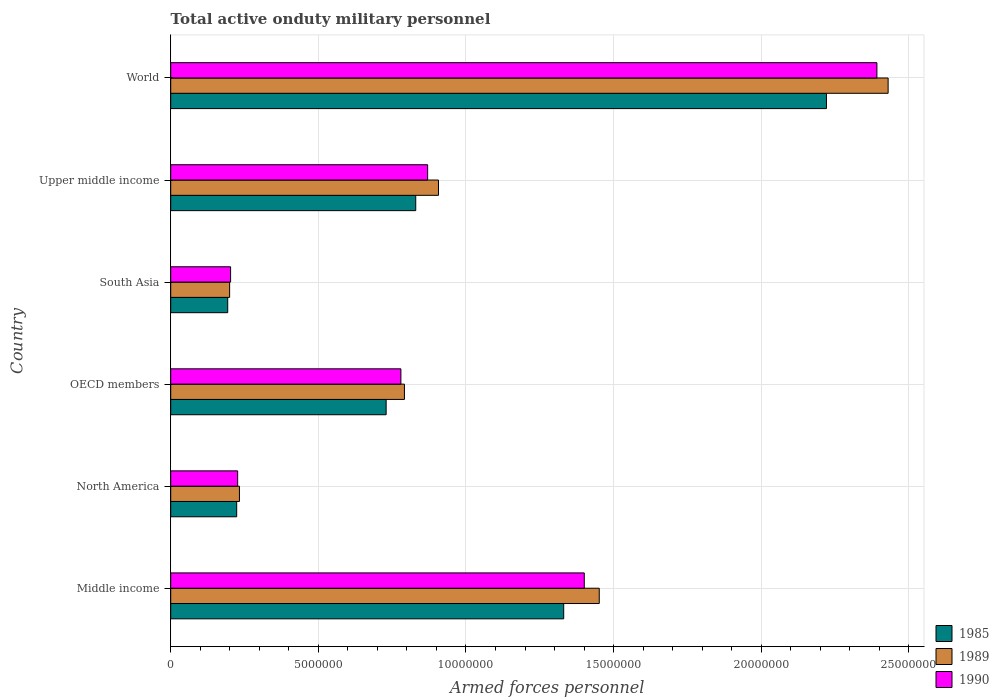How many groups of bars are there?
Your answer should be very brief. 6. Are the number of bars on each tick of the Y-axis equal?
Offer a very short reply. Yes. How many bars are there on the 1st tick from the bottom?
Your answer should be very brief. 3. What is the label of the 1st group of bars from the top?
Give a very brief answer. World. What is the number of armed forces personnel in 1985 in Upper middle income?
Offer a very short reply. 8.30e+06. Across all countries, what is the maximum number of armed forces personnel in 1985?
Your answer should be compact. 2.22e+07. Across all countries, what is the minimum number of armed forces personnel in 1990?
Keep it short and to the point. 2.03e+06. In which country was the number of armed forces personnel in 1985 maximum?
Give a very brief answer. World. What is the total number of armed forces personnel in 1989 in the graph?
Your response must be concise. 6.01e+07. What is the difference between the number of armed forces personnel in 1989 in Middle income and that in Upper middle income?
Offer a very short reply. 5.44e+06. What is the difference between the number of armed forces personnel in 1990 in Middle income and the number of armed forces personnel in 1989 in North America?
Your answer should be very brief. 1.17e+07. What is the average number of armed forces personnel in 1989 per country?
Keep it short and to the point. 1.00e+07. What is the difference between the number of armed forces personnel in 1985 and number of armed forces personnel in 1989 in Upper middle income?
Offer a very short reply. -7.71e+05. What is the ratio of the number of armed forces personnel in 1985 in Middle income to that in World?
Provide a short and direct response. 0.6. Is the number of armed forces personnel in 1989 in North America less than that in OECD members?
Provide a short and direct response. Yes. What is the difference between the highest and the second highest number of armed forces personnel in 1989?
Give a very brief answer. 9.78e+06. What is the difference between the highest and the lowest number of armed forces personnel in 1990?
Your answer should be very brief. 2.19e+07. In how many countries, is the number of armed forces personnel in 1985 greater than the average number of armed forces personnel in 1985 taken over all countries?
Keep it short and to the point. 2. What does the 2nd bar from the bottom in South Asia represents?
Your response must be concise. 1989. Is it the case that in every country, the sum of the number of armed forces personnel in 1989 and number of armed forces personnel in 1985 is greater than the number of armed forces personnel in 1990?
Your answer should be very brief. Yes. How many countries are there in the graph?
Provide a short and direct response. 6. What is the difference between two consecutive major ticks on the X-axis?
Provide a succinct answer. 5.00e+06. Are the values on the major ticks of X-axis written in scientific E-notation?
Make the answer very short. No. Does the graph contain grids?
Keep it short and to the point. Yes. How many legend labels are there?
Offer a terse response. 3. What is the title of the graph?
Ensure brevity in your answer.  Total active onduty military personnel. What is the label or title of the X-axis?
Your response must be concise. Armed forces personnel. What is the Armed forces personnel in 1985 in Middle income?
Give a very brief answer. 1.33e+07. What is the Armed forces personnel of 1989 in Middle income?
Give a very brief answer. 1.45e+07. What is the Armed forces personnel of 1990 in Middle income?
Your answer should be very brief. 1.40e+07. What is the Armed forces personnel of 1985 in North America?
Keep it short and to the point. 2.23e+06. What is the Armed forces personnel in 1989 in North America?
Offer a very short reply. 2.33e+06. What is the Armed forces personnel in 1990 in North America?
Provide a short and direct response. 2.27e+06. What is the Armed forces personnel in 1985 in OECD members?
Your answer should be very brief. 7.30e+06. What is the Armed forces personnel of 1989 in OECD members?
Your answer should be compact. 7.92e+06. What is the Armed forces personnel of 1990 in OECD members?
Your answer should be compact. 7.80e+06. What is the Armed forces personnel in 1985 in South Asia?
Provide a succinct answer. 1.93e+06. What is the Armed forces personnel in 1989 in South Asia?
Make the answer very short. 2.00e+06. What is the Armed forces personnel of 1990 in South Asia?
Offer a very short reply. 2.03e+06. What is the Armed forces personnel of 1985 in Upper middle income?
Make the answer very short. 8.30e+06. What is the Armed forces personnel in 1989 in Upper middle income?
Ensure brevity in your answer.  9.07e+06. What is the Armed forces personnel in 1990 in Upper middle income?
Provide a short and direct response. 8.70e+06. What is the Armed forces personnel of 1985 in World?
Offer a terse response. 2.22e+07. What is the Armed forces personnel of 1989 in World?
Offer a terse response. 2.43e+07. What is the Armed forces personnel in 1990 in World?
Keep it short and to the point. 2.39e+07. Across all countries, what is the maximum Armed forces personnel in 1985?
Offer a very short reply. 2.22e+07. Across all countries, what is the maximum Armed forces personnel of 1989?
Your answer should be compact. 2.43e+07. Across all countries, what is the maximum Armed forces personnel in 1990?
Make the answer very short. 2.39e+07. Across all countries, what is the minimum Armed forces personnel in 1985?
Provide a succinct answer. 1.93e+06. Across all countries, what is the minimum Armed forces personnel in 1989?
Make the answer very short. 2.00e+06. Across all countries, what is the minimum Armed forces personnel in 1990?
Provide a short and direct response. 2.03e+06. What is the total Armed forces personnel of 1985 in the graph?
Ensure brevity in your answer.  5.53e+07. What is the total Armed forces personnel of 1989 in the graph?
Your response must be concise. 6.01e+07. What is the total Armed forces personnel in 1990 in the graph?
Give a very brief answer. 5.87e+07. What is the difference between the Armed forces personnel in 1985 in Middle income and that in North America?
Provide a short and direct response. 1.11e+07. What is the difference between the Armed forces personnel of 1989 in Middle income and that in North America?
Your response must be concise. 1.22e+07. What is the difference between the Armed forces personnel of 1990 in Middle income and that in North America?
Keep it short and to the point. 1.17e+07. What is the difference between the Armed forces personnel in 1985 in Middle income and that in OECD members?
Provide a short and direct response. 6.01e+06. What is the difference between the Armed forces personnel in 1989 in Middle income and that in OECD members?
Provide a succinct answer. 6.60e+06. What is the difference between the Armed forces personnel of 1990 in Middle income and that in OECD members?
Offer a very short reply. 6.21e+06. What is the difference between the Armed forces personnel in 1985 in Middle income and that in South Asia?
Your response must be concise. 1.14e+07. What is the difference between the Armed forces personnel in 1989 in Middle income and that in South Asia?
Your response must be concise. 1.25e+07. What is the difference between the Armed forces personnel in 1990 in Middle income and that in South Asia?
Keep it short and to the point. 1.20e+07. What is the difference between the Armed forces personnel in 1985 in Middle income and that in Upper middle income?
Make the answer very short. 5.01e+06. What is the difference between the Armed forces personnel of 1989 in Middle income and that in Upper middle income?
Provide a succinct answer. 5.44e+06. What is the difference between the Armed forces personnel in 1990 in Middle income and that in Upper middle income?
Offer a very short reply. 5.30e+06. What is the difference between the Armed forces personnel of 1985 in Middle income and that in World?
Offer a terse response. -8.90e+06. What is the difference between the Armed forces personnel of 1989 in Middle income and that in World?
Your answer should be compact. -9.78e+06. What is the difference between the Armed forces personnel in 1990 in Middle income and that in World?
Keep it short and to the point. -9.91e+06. What is the difference between the Armed forces personnel in 1985 in North America and that in OECD members?
Ensure brevity in your answer.  -5.06e+06. What is the difference between the Armed forces personnel of 1989 in North America and that in OECD members?
Your answer should be compact. -5.59e+06. What is the difference between the Armed forces personnel of 1990 in North America and that in OECD members?
Ensure brevity in your answer.  -5.53e+06. What is the difference between the Armed forces personnel of 1985 in North America and that in South Asia?
Give a very brief answer. 3.04e+05. What is the difference between the Armed forces personnel in 1989 in North America and that in South Asia?
Give a very brief answer. 3.33e+05. What is the difference between the Armed forces personnel in 1990 in North America and that in South Asia?
Provide a short and direct response. 2.39e+05. What is the difference between the Armed forces personnel in 1985 in North America and that in Upper middle income?
Offer a very short reply. -6.06e+06. What is the difference between the Armed forces personnel of 1989 in North America and that in Upper middle income?
Provide a succinct answer. -6.74e+06. What is the difference between the Armed forces personnel of 1990 in North America and that in Upper middle income?
Provide a short and direct response. -6.44e+06. What is the difference between the Armed forces personnel in 1985 in North America and that in World?
Ensure brevity in your answer.  -2.00e+07. What is the difference between the Armed forces personnel of 1989 in North America and that in World?
Give a very brief answer. -2.20e+07. What is the difference between the Armed forces personnel of 1990 in North America and that in World?
Your answer should be very brief. -2.17e+07. What is the difference between the Armed forces personnel of 1985 in OECD members and that in South Asia?
Your response must be concise. 5.37e+06. What is the difference between the Armed forces personnel of 1989 in OECD members and that in South Asia?
Keep it short and to the point. 5.92e+06. What is the difference between the Armed forces personnel of 1990 in OECD members and that in South Asia?
Give a very brief answer. 5.77e+06. What is the difference between the Armed forces personnel of 1985 in OECD members and that in Upper middle income?
Offer a very short reply. -1.00e+06. What is the difference between the Armed forces personnel in 1989 in OECD members and that in Upper middle income?
Provide a succinct answer. -1.15e+06. What is the difference between the Armed forces personnel of 1990 in OECD members and that in Upper middle income?
Your response must be concise. -9.06e+05. What is the difference between the Armed forces personnel of 1985 in OECD members and that in World?
Provide a short and direct response. -1.49e+07. What is the difference between the Armed forces personnel in 1989 in OECD members and that in World?
Make the answer very short. -1.64e+07. What is the difference between the Armed forces personnel in 1990 in OECD members and that in World?
Give a very brief answer. -1.61e+07. What is the difference between the Armed forces personnel in 1985 in South Asia and that in Upper middle income?
Your answer should be very brief. -6.37e+06. What is the difference between the Armed forces personnel in 1989 in South Asia and that in Upper middle income?
Provide a short and direct response. -7.07e+06. What is the difference between the Armed forces personnel in 1990 in South Asia and that in Upper middle income?
Keep it short and to the point. -6.67e+06. What is the difference between the Armed forces personnel in 1985 in South Asia and that in World?
Your response must be concise. -2.03e+07. What is the difference between the Armed forces personnel in 1989 in South Asia and that in World?
Your answer should be compact. -2.23e+07. What is the difference between the Armed forces personnel in 1990 in South Asia and that in World?
Give a very brief answer. -2.19e+07. What is the difference between the Armed forces personnel in 1985 in Upper middle income and that in World?
Offer a terse response. -1.39e+07. What is the difference between the Armed forces personnel of 1989 in Upper middle income and that in World?
Your response must be concise. -1.52e+07. What is the difference between the Armed forces personnel of 1990 in Upper middle income and that in World?
Provide a short and direct response. -1.52e+07. What is the difference between the Armed forces personnel in 1985 in Middle income and the Armed forces personnel in 1989 in North America?
Make the answer very short. 1.10e+07. What is the difference between the Armed forces personnel of 1985 in Middle income and the Armed forces personnel of 1990 in North America?
Provide a short and direct response. 1.10e+07. What is the difference between the Armed forces personnel in 1989 in Middle income and the Armed forces personnel in 1990 in North America?
Make the answer very short. 1.22e+07. What is the difference between the Armed forces personnel of 1985 in Middle income and the Armed forces personnel of 1989 in OECD members?
Give a very brief answer. 5.39e+06. What is the difference between the Armed forces personnel in 1985 in Middle income and the Armed forces personnel in 1990 in OECD members?
Keep it short and to the point. 5.51e+06. What is the difference between the Armed forces personnel of 1989 in Middle income and the Armed forces personnel of 1990 in OECD members?
Your response must be concise. 6.72e+06. What is the difference between the Armed forces personnel in 1985 in Middle income and the Armed forces personnel in 1989 in South Asia?
Your response must be concise. 1.13e+07. What is the difference between the Armed forces personnel in 1985 in Middle income and the Armed forces personnel in 1990 in South Asia?
Provide a short and direct response. 1.13e+07. What is the difference between the Armed forces personnel of 1989 in Middle income and the Armed forces personnel of 1990 in South Asia?
Offer a terse response. 1.25e+07. What is the difference between the Armed forces personnel of 1985 in Middle income and the Armed forces personnel of 1989 in Upper middle income?
Your answer should be very brief. 4.24e+06. What is the difference between the Armed forces personnel of 1985 in Middle income and the Armed forces personnel of 1990 in Upper middle income?
Make the answer very short. 4.61e+06. What is the difference between the Armed forces personnel in 1989 in Middle income and the Armed forces personnel in 1990 in Upper middle income?
Provide a short and direct response. 5.81e+06. What is the difference between the Armed forces personnel of 1985 in Middle income and the Armed forces personnel of 1989 in World?
Make the answer very short. -1.10e+07. What is the difference between the Armed forces personnel of 1985 in Middle income and the Armed forces personnel of 1990 in World?
Keep it short and to the point. -1.06e+07. What is the difference between the Armed forces personnel of 1989 in Middle income and the Armed forces personnel of 1990 in World?
Provide a succinct answer. -9.40e+06. What is the difference between the Armed forces personnel in 1985 in North America and the Armed forces personnel in 1989 in OECD members?
Make the answer very short. -5.68e+06. What is the difference between the Armed forces personnel in 1985 in North America and the Armed forces personnel in 1990 in OECD members?
Ensure brevity in your answer.  -5.56e+06. What is the difference between the Armed forces personnel of 1989 in North America and the Armed forces personnel of 1990 in OECD members?
Your answer should be compact. -5.47e+06. What is the difference between the Armed forces personnel in 1985 in North America and the Armed forces personnel in 1989 in South Asia?
Your answer should be compact. 2.40e+05. What is the difference between the Armed forces personnel of 1985 in North America and the Armed forces personnel of 1990 in South Asia?
Give a very brief answer. 2.07e+05. What is the difference between the Armed forces personnel in 1985 in North America and the Armed forces personnel in 1989 in Upper middle income?
Provide a succinct answer. -6.83e+06. What is the difference between the Armed forces personnel in 1985 in North America and the Armed forces personnel in 1990 in Upper middle income?
Provide a short and direct response. -6.47e+06. What is the difference between the Armed forces personnel in 1989 in North America and the Armed forces personnel in 1990 in Upper middle income?
Provide a succinct answer. -6.37e+06. What is the difference between the Armed forces personnel of 1985 in North America and the Armed forces personnel of 1989 in World?
Offer a terse response. -2.21e+07. What is the difference between the Armed forces personnel of 1985 in North America and the Armed forces personnel of 1990 in World?
Offer a very short reply. -2.17e+07. What is the difference between the Armed forces personnel of 1989 in North America and the Armed forces personnel of 1990 in World?
Provide a short and direct response. -2.16e+07. What is the difference between the Armed forces personnel in 1985 in OECD members and the Armed forces personnel in 1989 in South Asia?
Offer a very short reply. 5.30e+06. What is the difference between the Armed forces personnel of 1985 in OECD members and the Armed forces personnel of 1990 in South Asia?
Keep it short and to the point. 5.27e+06. What is the difference between the Armed forces personnel of 1989 in OECD members and the Armed forces personnel of 1990 in South Asia?
Offer a terse response. 5.89e+06. What is the difference between the Armed forces personnel in 1985 in OECD members and the Armed forces personnel in 1989 in Upper middle income?
Keep it short and to the point. -1.77e+06. What is the difference between the Armed forces personnel of 1985 in OECD members and the Armed forces personnel of 1990 in Upper middle income?
Give a very brief answer. -1.41e+06. What is the difference between the Armed forces personnel of 1989 in OECD members and the Armed forces personnel of 1990 in Upper middle income?
Provide a short and direct response. -7.86e+05. What is the difference between the Armed forces personnel of 1985 in OECD members and the Armed forces personnel of 1989 in World?
Offer a terse response. -1.70e+07. What is the difference between the Armed forces personnel in 1985 in OECD members and the Armed forces personnel in 1990 in World?
Your answer should be very brief. -1.66e+07. What is the difference between the Armed forces personnel in 1989 in OECD members and the Armed forces personnel in 1990 in World?
Your answer should be compact. -1.60e+07. What is the difference between the Armed forces personnel of 1985 in South Asia and the Armed forces personnel of 1989 in Upper middle income?
Make the answer very short. -7.14e+06. What is the difference between the Armed forces personnel in 1985 in South Asia and the Armed forces personnel in 1990 in Upper middle income?
Offer a very short reply. -6.77e+06. What is the difference between the Armed forces personnel of 1989 in South Asia and the Armed forces personnel of 1990 in Upper middle income?
Your answer should be compact. -6.71e+06. What is the difference between the Armed forces personnel of 1985 in South Asia and the Armed forces personnel of 1989 in World?
Ensure brevity in your answer.  -2.24e+07. What is the difference between the Armed forces personnel of 1985 in South Asia and the Armed forces personnel of 1990 in World?
Your answer should be very brief. -2.20e+07. What is the difference between the Armed forces personnel of 1989 in South Asia and the Armed forces personnel of 1990 in World?
Make the answer very short. -2.19e+07. What is the difference between the Armed forces personnel in 1985 in Upper middle income and the Armed forces personnel in 1989 in World?
Keep it short and to the point. -1.60e+07. What is the difference between the Armed forces personnel in 1985 in Upper middle income and the Armed forces personnel in 1990 in World?
Provide a short and direct response. -1.56e+07. What is the difference between the Armed forces personnel of 1989 in Upper middle income and the Armed forces personnel of 1990 in World?
Provide a short and direct response. -1.48e+07. What is the average Armed forces personnel of 1985 per country?
Ensure brevity in your answer.  9.21e+06. What is the average Armed forces personnel of 1989 per country?
Provide a short and direct response. 1.00e+07. What is the average Armed forces personnel of 1990 per country?
Ensure brevity in your answer.  9.79e+06. What is the difference between the Armed forces personnel in 1985 and Armed forces personnel in 1989 in Middle income?
Offer a very short reply. -1.20e+06. What is the difference between the Armed forces personnel in 1985 and Armed forces personnel in 1990 in Middle income?
Your answer should be very brief. -6.97e+05. What is the difference between the Armed forces personnel of 1989 and Armed forces personnel of 1990 in Middle income?
Provide a succinct answer. 5.07e+05. What is the difference between the Armed forces personnel in 1985 and Armed forces personnel in 1989 in North America?
Provide a succinct answer. -9.34e+04. What is the difference between the Armed forces personnel in 1985 and Armed forces personnel in 1990 in North America?
Your answer should be compact. -3.24e+04. What is the difference between the Armed forces personnel in 1989 and Armed forces personnel in 1990 in North America?
Offer a terse response. 6.10e+04. What is the difference between the Armed forces personnel of 1985 and Armed forces personnel of 1989 in OECD members?
Keep it short and to the point. -6.20e+05. What is the difference between the Armed forces personnel in 1985 and Armed forces personnel in 1990 in OECD members?
Offer a very short reply. -5.00e+05. What is the difference between the Armed forces personnel of 1985 and Armed forces personnel of 1989 in South Asia?
Ensure brevity in your answer.  -6.43e+04. What is the difference between the Armed forces personnel of 1985 and Armed forces personnel of 1990 in South Asia?
Your answer should be compact. -9.73e+04. What is the difference between the Armed forces personnel of 1989 and Armed forces personnel of 1990 in South Asia?
Provide a succinct answer. -3.30e+04. What is the difference between the Armed forces personnel in 1985 and Armed forces personnel in 1989 in Upper middle income?
Provide a short and direct response. -7.71e+05. What is the difference between the Armed forces personnel of 1985 and Armed forces personnel of 1990 in Upper middle income?
Ensure brevity in your answer.  -4.04e+05. What is the difference between the Armed forces personnel in 1989 and Armed forces personnel in 1990 in Upper middle income?
Give a very brief answer. 3.67e+05. What is the difference between the Armed forces personnel of 1985 and Armed forces personnel of 1989 in World?
Keep it short and to the point. -2.09e+06. What is the difference between the Armed forces personnel of 1985 and Armed forces personnel of 1990 in World?
Provide a succinct answer. -1.71e+06. What is the difference between the Armed forces personnel in 1989 and Armed forces personnel in 1990 in World?
Provide a short and direct response. 3.80e+05. What is the ratio of the Armed forces personnel in 1985 in Middle income to that in North America?
Your response must be concise. 5.96. What is the ratio of the Armed forces personnel in 1989 in Middle income to that in North America?
Provide a succinct answer. 6.23. What is the ratio of the Armed forces personnel of 1990 in Middle income to that in North America?
Keep it short and to the point. 6.18. What is the ratio of the Armed forces personnel in 1985 in Middle income to that in OECD members?
Offer a very short reply. 1.82. What is the ratio of the Armed forces personnel of 1989 in Middle income to that in OECD members?
Your response must be concise. 1.83. What is the ratio of the Armed forces personnel in 1990 in Middle income to that in OECD members?
Give a very brief answer. 1.8. What is the ratio of the Armed forces personnel of 1985 in Middle income to that in South Asia?
Give a very brief answer. 6.89. What is the ratio of the Armed forces personnel in 1989 in Middle income to that in South Asia?
Your response must be concise. 7.28. What is the ratio of the Armed forces personnel of 1990 in Middle income to that in South Asia?
Your answer should be compact. 6.91. What is the ratio of the Armed forces personnel in 1985 in Middle income to that in Upper middle income?
Offer a very short reply. 1.6. What is the ratio of the Armed forces personnel in 1989 in Middle income to that in Upper middle income?
Ensure brevity in your answer.  1.6. What is the ratio of the Armed forces personnel in 1990 in Middle income to that in Upper middle income?
Provide a succinct answer. 1.61. What is the ratio of the Armed forces personnel of 1985 in Middle income to that in World?
Provide a short and direct response. 0.6. What is the ratio of the Armed forces personnel of 1989 in Middle income to that in World?
Provide a short and direct response. 0.6. What is the ratio of the Armed forces personnel of 1990 in Middle income to that in World?
Provide a succinct answer. 0.59. What is the ratio of the Armed forces personnel in 1985 in North America to that in OECD members?
Ensure brevity in your answer.  0.31. What is the ratio of the Armed forces personnel in 1989 in North America to that in OECD members?
Your answer should be compact. 0.29. What is the ratio of the Armed forces personnel in 1990 in North America to that in OECD members?
Ensure brevity in your answer.  0.29. What is the ratio of the Armed forces personnel in 1985 in North America to that in South Asia?
Your answer should be very brief. 1.16. What is the ratio of the Armed forces personnel in 1989 in North America to that in South Asia?
Your response must be concise. 1.17. What is the ratio of the Armed forces personnel in 1990 in North America to that in South Asia?
Offer a terse response. 1.12. What is the ratio of the Armed forces personnel in 1985 in North America to that in Upper middle income?
Provide a short and direct response. 0.27. What is the ratio of the Armed forces personnel in 1989 in North America to that in Upper middle income?
Provide a short and direct response. 0.26. What is the ratio of the Armed forces personnel of 1990 in North America to that in Upper middle income?
Your response must be concise. 0.26. What is the ratio of the Armed forces personnel in 1985 in North America to that in World?
Your answer should be very brief. 0.1. What is the ratio of the Armed forces personnel in 1989 in North America to that in World?
Provide a short and direct response. 0.1. What is the ratio of the Armed forces personnel of 1990 in North America to that in World?
Offer a very short reply. 0.09. What is the ratio of the Armed forces personnel of 1985 in OECD members to that in South Asia?
Offer a terse response. 3.78. What is the ratio of the Armed forces personnel of 1989 in OECD members to that in South Asia?
Your answer should be compact. 3.97. What is the ratio of the Armed forces personnel of 1990 in OECD members to that in South Asia?
Ensure brevity in your answer.  3.84. What is the ratio of the Armed forces personnel of 1985 in OECD members to that in Upper middle income?
Offer a very short reply. 0.88. What is the ratio of the Armed forces personnel of 1989 in OECD members to that in Upper middle income?
Offer a terse response. 0.87. What is the ratio of the Armed forces personnel of 1990 in OECD members to that in Upper middle income?
Keep it short and to the point. 0.9. What is the ratio of the Armed forces personnel in 1985 in OECD members to that in World?
Provide a succinct answer. 0.33. What is the ratio of the Armed forces personnel in 1989 in OECD members to that in World?
Keep it short and to the point. 0.33. What is the ratio of the Armed forces personnel in 1990 in OECD members to that in World?
Offer a very short reply. 0.33. What is the ratio of the Armed forces personnel in 1985 in South Asia to that in Upper middle income?
Ensure brevity in your answer.  0.23. What is the ratio of the Armed forces personnel in 1989 in South Asia to that in Upper middle income?
Provide a short and direct response. 0.22. What is the ratio of the Armed forces personnel of 1990 in South Asia to that in Upper middle income?
Offer a terse response. 0.23. What is the ratio of the Armed forces personnel in 1985 in South Asia to that in World?
Ensure brevity in your answer.  0.09. What is the ratio of the Armed forces personnel in 1989 in South Asia to that in World?
Ensure brevity in your answer.  0.08. What is the ratio of the Armed forces personnel in 1990 in South Asia to that in World?
Offer a very short reply. 0.08. What is the ratio of the Armed forces personnel of 1985 in Upper middle income to that in World?
Keep it short and to the point. 0.37. What is the ratio of the Armed forces personnel of 1989 in Upper middle income to that in World?
Keep it short and to the point. 0.37. What is the ratio of the Armed forces personnel in 1990 in Upper middle income to that in World?
Give a very brief answer. 0.36. What is the difference between the highest and the second highest Armed forces personnel of 1985?
Ensure brevity in your answer.  8.90e+06. What is the difference between the highest and the second highest Armed forces personnel of 1989?
Offer a very short reply. 9.78e+06. What is the difference between the highest and the second highest Armed forces personnel in 1990?
Offer a terse response. 9.91e+06. What is the difference between the highest and the lowest Armed forces personnel of 1985?
Offer a terse response. 2.03e+07. What is the difference between the highest and the lowest Armed forces personnel in 1989?
Provide a short and direct response. 2.23e+07. What is the difference between the highest and the lowest Armed forces personnel of 1990?
Offer a terse response. 2.19e+07. 